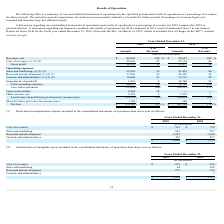From Marin Software's financial document, What are the company's respective net revenue from operations in 2018 and 2019? The document shows two values: $58,631 and $49,036 (in thousands). From the document: "Revenues, net $ 49,036 100 % $ 58,631 100 % Revenues, net $ 49,036 100 % $ 58,631 100 %..." Also, What are the company's respective cost of revenue from operations in 2018 and 2019? The document shows two values: 27,154 and 22,843 (in thousands). From the document: "Cost of revenues (1) (2) (3) 22,843 47 27,154 46 Cost of revenues (1) (2) (3) 22,843 47 27,154 46..." Also, What are the company's respective gross profit from operations in 2018 and 2019? The document shows two values: 31,477 and 26,193 (in thousands). From the document: "Gross profit 26,193 53 31,477 54 Gross profit 26,193 53 31,477 54..." Also, can you calculate: What is the company's average net revenue from its operations in 2018 and 2019? To answer this question, I need to perform calculations using the financial data. The calculation is: (58,631 + 49,036)/2, which equals 53833.5 (in thousands). This is based on the information: "Revenues, net $ 49,036 100 % $ 58,631 100 % Revenues, net $ 49,036 100 % $ 58,631 100 %..." The key data points involved are: 49,036, 58,631. Also, can you calculate: What is the company's percentage change in its net revenue from operations between 2018 and 2019? To answer this question, I need to perform calculations using the financial data. The calculation is: (49,036 - 58,631)/58,631 , which equals -16.37 (percentage). This is based on the information: "Revenues, net $ 49,036 100 % $ 58,631 100 % Revenues, net $ 49,036 100 % $ 58,631 100 %..." The key data points involved are: 49,036, 58,631. Also, can you calculate: What is the company's percentage change in its gross profit from operations between 2018 and 2019? To answer this question, I need to perform calculations using the financial data. The calculation is: (26,193 - 31,477)/31,477 , which equals -16.79 (percentage). This is based on the information: "Gross profit 26,193 53 31,477 54 Gross profit 26,193 53 31,477 54..." The key data points involved are: 26,193, 31,477. 